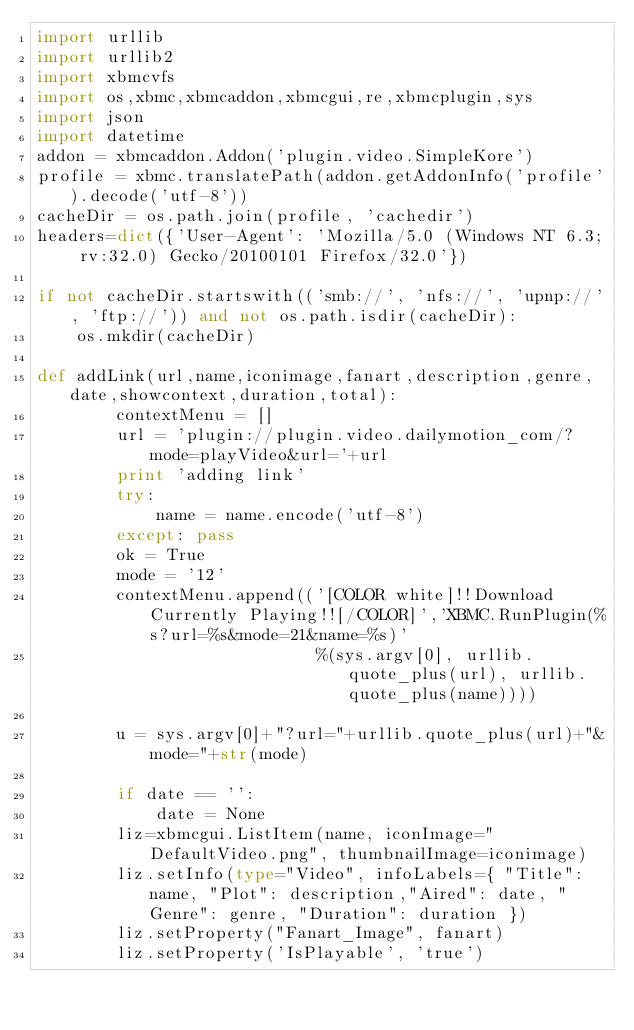Convert code to text. <code><loc_0><loc_0><loc_500><loc_500><_Python_>import urllib
import urllib2
import xbmcvfs
import os,xbmc,xbmcaddon,xbmcgui,re,xbmcplugin,sys
import json
import datetime
addon = xbmcaddon.Addon('plugin.video.SimpleKore')
profile = xbmc.translatePath(addon.getAddonInfo('profile').decode('utf-8'))
cacheDir = os.path.join(profile, 'cachedir')
headers=dict({'User-Agent': 'Mozilla/5.0 (Windows NT 6.3; rv:32.0) Gecko/20100101 Firefox/32.0'})

if not cacheDir.startswith(('smb://', 'nfs://', 'upnp://', 'ftp://')) and not os.path.isdir(cacheDir):
    os.mkdir(cacheDir)

def addLink(url,name,iconimage,fanart,description,genre,date,showcontext,duration,total):
        contextMenu = []
        url = 'plugin://plugin.video.dailymotion_com/?mode=playVideo&url='+url
        print 'adding link'
        try:
            name = name.encode('utf-8')
        except: pass
        ok = True
        mode = '12'
        contextMenu.append(('[COLOR white]!!Download Currently Playing!![/COLOR]','XBMC.RunPlugin(%s?url=%s&mode=21&name=%s)'
                            %(sys.argv[0], urllib.quote_plus(url), urllib.quote_plus(name))))             
            
        u = sys.argv[0]+"?url="+urllib.quote_plus(url)+"&mode="+str(mode)
      
        if date == '':
            date = None
        liz=xbmcgui.ListItem(name, iconImage="DefaultVideo.png", thumbnailImage=iconimage)
        liz.setInfo(type="Video", infoLabels={ "Title": name, "Plot": description,"Aired": date, "Genre": genre, "Duration": duration })
        liz.setProperty("Fanart_Image", fanart)
        liz.setProperty('IsPlayable', 'true')</code> 